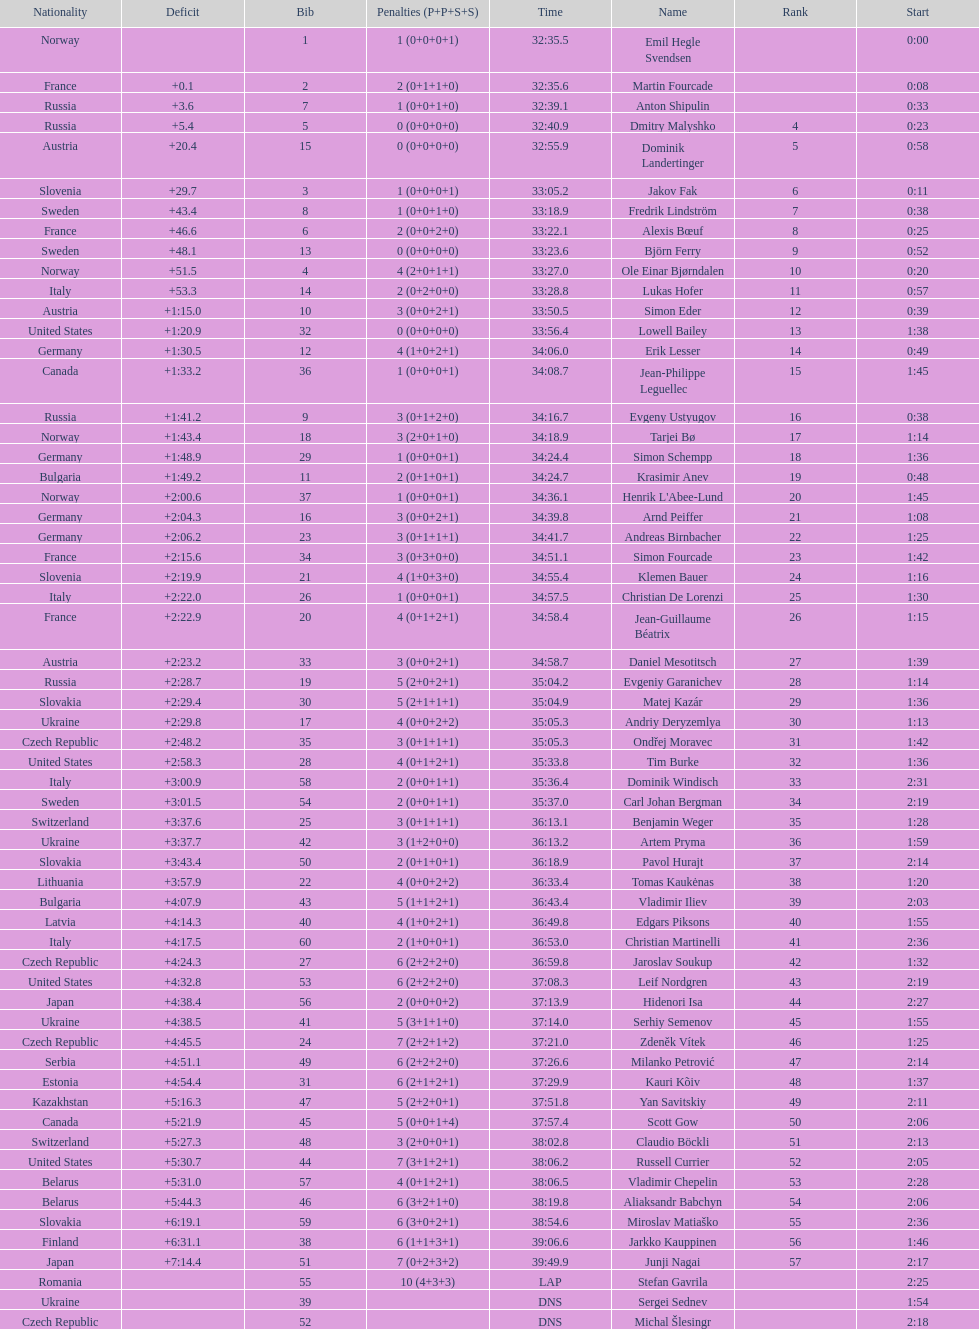Between bjorn ferry, simon elder and erik lesser - who had the most penalties? Erik Lesser. 